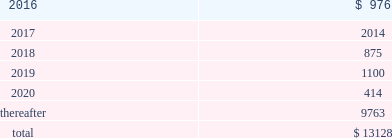Devon energy corporation and subsidiaries notes to consolidated financial statements 2013 ( continued ) debt maturities as of december 31 , 2015 , excluding premiums and discounts , are as follows ( millions ) : .
Credit lines devon has a $ 3.0 billion senior credit facility .
The maturity date for $ 30 million of the senior credit facility is october 24 , 2017 .
The maturity date for $ 164 million of the senior credit facility is october 24 , 2018 .
The maturity date for the remaining $ 2.8 billion is october 24 , 2019 .
Amounts borrowed under the senior credit facility may , at the election of devon , bear interest at various fixed rate options for periods of up to twelve months .
Such rates are generally less than the prime rate .
However , devon may elect to borrow at the prime rate .
The senior credit facility currently provides for an annual facility fee of $ 3.8 million that is payable quarterly in arrears .
As of december 31 , 2015 , there were no borrowings under the senior credit facility .
The senior credit facility contains only one material financial covenant .
This covenant requires devon 2019s ratio of total funded debt to total capitalization , as defined in the credit agreement , to be no greater than 65% ( 65 % ) .
The credit agreement contains definitions of total funded debt and total capitalization that include adjustments to the respective amounts reported in the accompanying consolidated financial statements .
Also , total capitalization is adjusted to add back noncash financial write-downs such as full cost ceiling impairments or goodwill impairments .
As of december 31 , 2015 , devon was in compliance with this covenant with a debt-to- capitalization ratio of 23.7% ( 23.7 % ) .
Commercial paper devon 2019s senior credit facility supports its $ 3.0 billion of short-term credit under its commercial paper program .
Commercial paper debt generally has a maturity of between 1 and 90 days , although it can have a maturity of up to 365 days , and bears interest at rates agreed to at the time of the borrowing .
The interest rate is generally based on a standard index such as the federal funds rate , libor or the money market rate as found in the commercial paper market .
As of december 31 , 2015 , devon 2019s outstanding commercial paper borrowings had a weighted-average borrowing rate of 0.63% ( 0.63 % ) .
Issuance of senior notes in june 2015 , devon issued $ 750 million of 5.0% ( 5.0 % ) senior notes due 2045 that are unsecured and unsubordinated obligations .
Devon used the net proceeds to repay the floating rate senior notes that matured on december 15 , 2015 , as well as outstanding commercial paper balances .
In december 2015 , in conjunction with the announcement of the powder river basin and stack acquisitions , devon issued $ 850 million of 5.85% ( 5.85 % ) senior notes due 2025 that are unsecured and unsubordinated obligations .
Devon used the net proceeds to fund the cash portion of these acquisitions. .
As of december 31 , 2015 what was the percent of the debt maturities scheduled to mature in 2016? 
Computations: (976 / 13128)
Answer: 0.07434. 